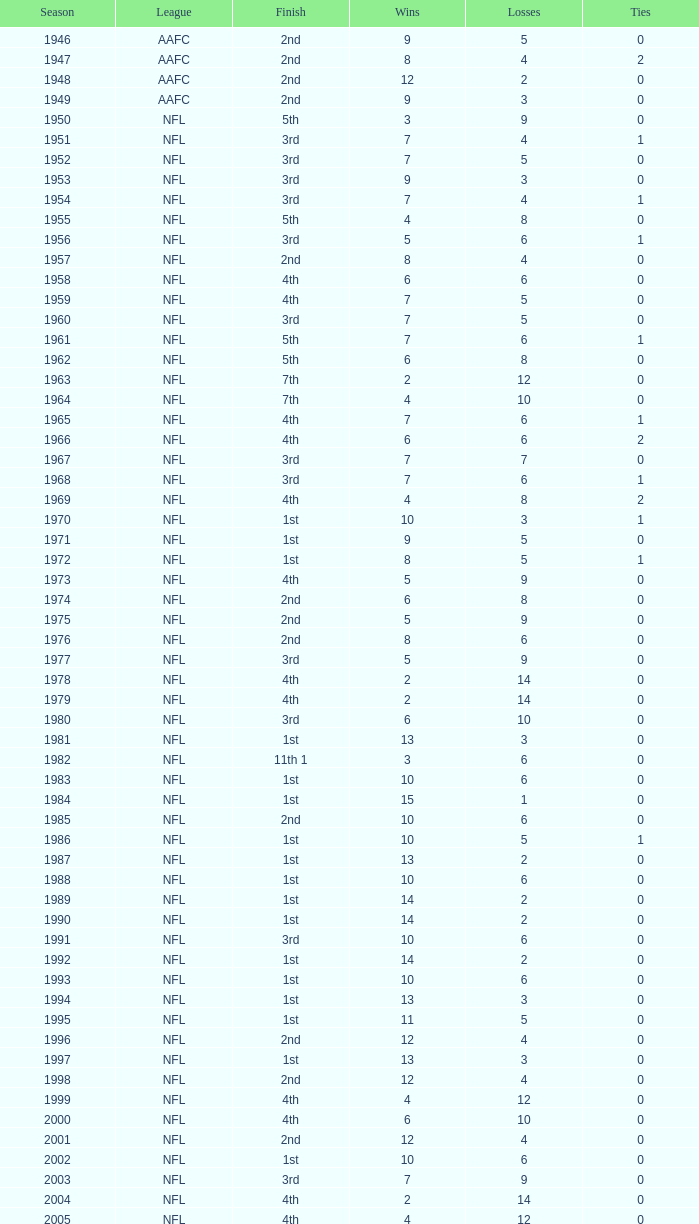Could you help me parse every detail presented in this table? {'header': ['Season', 'League', 'Finish', 'Wins', 'Losses', 'Ties'], 'rows': [['1946', 'AAFC', '2nd', '9', '5', '0'], ['1947', 'AAFC', '2nd', '8', '4', '2'], ['1948', 'AAFC', '2nd', '12', '2', '0'], ['1949', 'AAFC', '2nd', '9', '3', '0'], ['1950', 'NFL', '5th', '3', '9', '0'], ['1951', 'NFL', '3rd', '7', '4', '1'], ['1952', 'NFL', '3rd', '7', '5', '0'], ['1953', 'NFL', '3rd', '9', '3', '0'], ['1954', 'NFL', '3rd', '7', '4', '1'], ['1955', 'NFL', '5th', '4', '8', '0'], ['1956', 'NFL', '3rd', '5', '6', '1'], ['1957', 'NFL', '2nd', '8', '4', '0'], ['1958', 'NFL', '4th', '6', '6', '0'], ['1959', 'NFL', '4th', '7', '5', '0'], ['1960', 'NFL', '3rd', '7', '5', '0'], ['1961', 'NFL', '5th', '7', '6', '1'], ['1962', 'NFL', '5th', '6', '8', '0'], ['1963', 'NFL', '7th', '2', '12', '0'], ['1964', 'NFL', '7th', '4', '10', '0'], ['1965', 'NFL', '4th', '7', '6', '1'], ['1966', 'NFL', '4th', '6', '6', '2'], ['1967', 'NFL', '3rd', '7', '7', '0'], ['1968', 'NFL', '3rd', '7', '6', '1'], ['1969', 'NFL', '4th', '4', '8', '2'], ['1970', 'NFL', '1st', '10', '3', '1'], ['1971', 'NFL', '1st', '9', '5', '0'], ['1972', 'NFL', '1st', '8', '5', '1'], ['1973', 'NFL', '4th', '5', '9', '0'], ['1974', 'NFL', '2nd', '6', '8', '0'], ['1975', 'NFL', '2nd', '5', '9', '0'], ['1976', 'NFL', '2nd', '8', '6', '0'], ['1977', 'NFL', '3rd', '5', '9', '0'], ['1978', 'NFL', '4th', '2', '14', '0'], ['1979', 'NFL', '4th', '2', '14', '0'], ['1980', 'NFL', '3rd', '6', '10', '0'], ['1981', 'NFL', '1st', '13', '3', '0'], ['1982', 'NFL', '11th 1', '3', '6', '0'], ['1983', 'NFL', '1st', '10', '6', '0'], ['1984', 'NFL', '1st', '15', '1', '0'], ['1985', 'NFL', '2nd', '10', '6', '0'], ['1986', 'NFL', '1st', '10', '5', '1'], ['1987', 'NFL', '1st', '13', '2', '0'], ['1988', 'NFL', '1st', '10', '6', '0'], ['1989', 'NFL', '1st', '14', '2', '0'], ['1990', 'NFL', '1st', '14', '2', '0'], ['1991', 'NFL', '3rd', '10', '6', '0'], ['1992', 'NFL', '1st', '14', '2', '0'], ['1993', 'NFL', '1st', '10', '6', '0'], ['1994', 'NFL', '1st', '13', '3', '0'], ['1995', 'NFL', '1st', '11', '5', '0'], ['1996', 'NFL', '2nd', '12', '4', '0'], ['1997', 'NFL', '1st', '13', '3', '0'], ['1998', 'NFL', '2nd', '12', '4', '0'], ['1999', 'NFL', '4th', '4', '12', '0'], ['2000', 'NFL', '4th', '6', '10', '0'], ['2001', 'NFL', '2nd', '12', '4', '0'], ['2002', 'NFL', '1st', '10', '6', '0'], ['2003', 'NFL', '3rd', '7', '9', '0'], ['2004', 'NFL', '4th', '2', '14', '0'], ['2005', 'NFL', '4th', '4', '12', '0'], ['2006', 'NFL', '3rd', '7', '9', '0'], ['2007', 'NFL', '3rd', '5', '11', '0'], ['2008', 'NFL', '2nd', '7', '9', '0'], ['2009', 'NFL', '2nd', '8', '8', '0'], ['2010', 'NFL', '3rd', '6', '10', '0'], ['2011', 'NFL', '1st', '13', '3', '0'], ['2012', 'NFL', '1st', '11', '4', '1'], ['2013', 'NFL', '2nd', '6', '2', '0']]} What is the number of losses when the ties are lesser than 0? 0.0. 